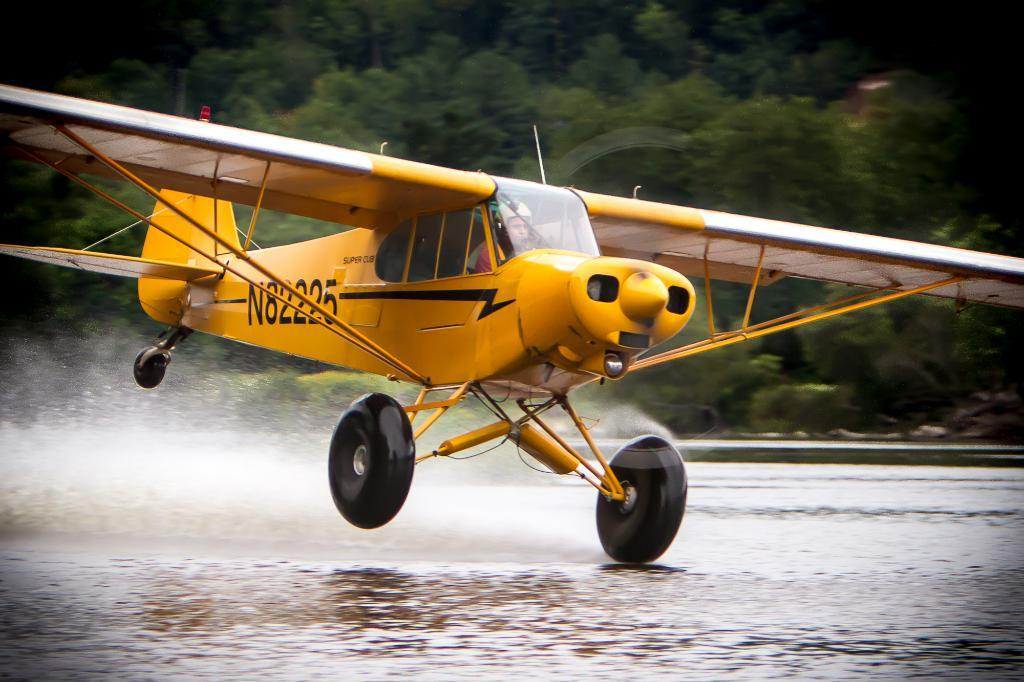What type of vehicle is in the image? There is a yellow color chopper in the image. What can be seen in the background of the image? There are trees in the background of the image. What is the condition of the land in the image? Water is present on the land in the image. What type of pot is being used to sing a song in the image? There is no pot or singing in the image; it features a yellow color chopper and trees in the background. 